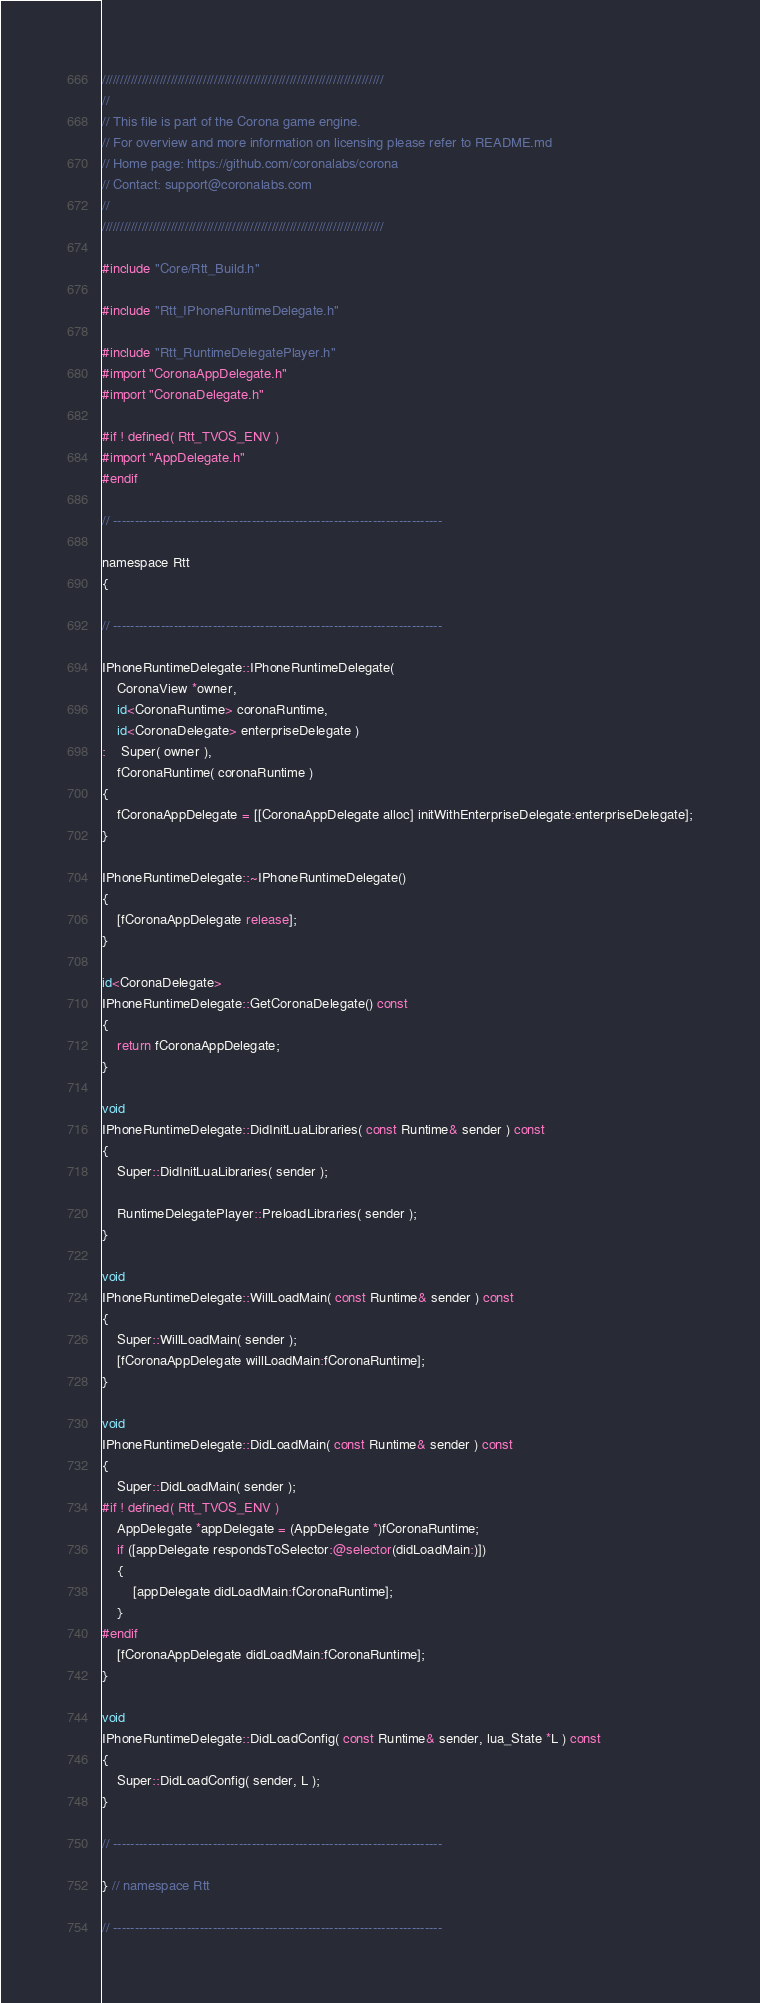Convert code to text. <code><loc_0><loc_0><loc_500><loc_500><_ObjectiveC_>//////////////////////////////////////////////////////////////////////////////
//
// This file is part of the Corona game engine.
// For overview and more information on licensing please refer to README.md 
// Home page: https://github.com/coronalabs/corona
// Contact: support@coronalabs.com
//
//////////////////////////////////////////////////////////////////////////////

#include "Core/Rtt_Build.h"

#include "Rtt_IPhoneRuntimeDelegate.h"

#include "Rtt_RuntimeDelegatePlayer.h"
#import "CoronaAppDelegate.h"
#import "CoronaDelegate.h"

#if ! defined( Rtt_TVOS_ENV )
#import "AppDelegate.h"
#endif

// ----------------------------------------------------------------------------

namespace Rtt
{

// ----------------------------------------------------------------------------

IPhoneRuntimeDelegate::IPhoneRuntimeDelegate(
	CoronaView *owner,
	id<CoronaRuntime> coronaRuntime,
	id<CoronaDelegate> enterpriseDelegate )
:	Super( owner ),
	fCoronaRuntime( coronaRuntime )
{
	fCoronaAppDelegate = [[CoronaAppDelegate alloc] initWithEnterpriseDelegate:enterpriseDelegate];
}

IPhoneRuntimeDelegate::~IPhoneRuntimeDelegate()
{
	[fCoronaAppDelegate release];
}

id<CoronaDelegate>
IPhoneRuntimeDelegate::GetCoronaDelegate() const
{
	return fCoronaAppDelegate;
}
	
void
IPhoneRuntimeDelegate::DidInitLuaLibraries( const Runtime& sender ) const
{
	Super::DidInitLuaLibraries( sender );

	RuntimeDelegatePlayer::PreloadLibraries( sender );
}

void
IPhoneRuntimeDelegate::WillLoadMain( const Runtime& sender ) const
{
	Super::WillLoadMain( sender );
	[fCoronaAppDelegate willLoadMain:fCoronaRuntime];
}

void
IPhoneRuntimeDelegate::DidLoadMain( const Runtime& sender ) const
{
	Super::DidLoadMain( sender );
#if ! defined( Rtt_TVOS_ENV )
	AppDelegate *appDelegate = (AppDelegate *)fCoronaRuntime;
	if ([appDelegate respondsToSelector:@selector(didLoadMain:)])
	{
		[appDelegate didLoadMain:fCoronaRuntime];
	}
#endif
	[fCoronaAppDelegate didLoadMain:fCoronaRuntime];
}

void
IPhoneRuntimeDelegate::DidLoadConfig( const Runtime& sender, lua_State *L ) const
{
	Super::DidLoadConfig( sender, L );
}

// ----------------------------------------------------------------------------

} // namespace Rtt

// ----------------------------------------------------------------------------

</code> 